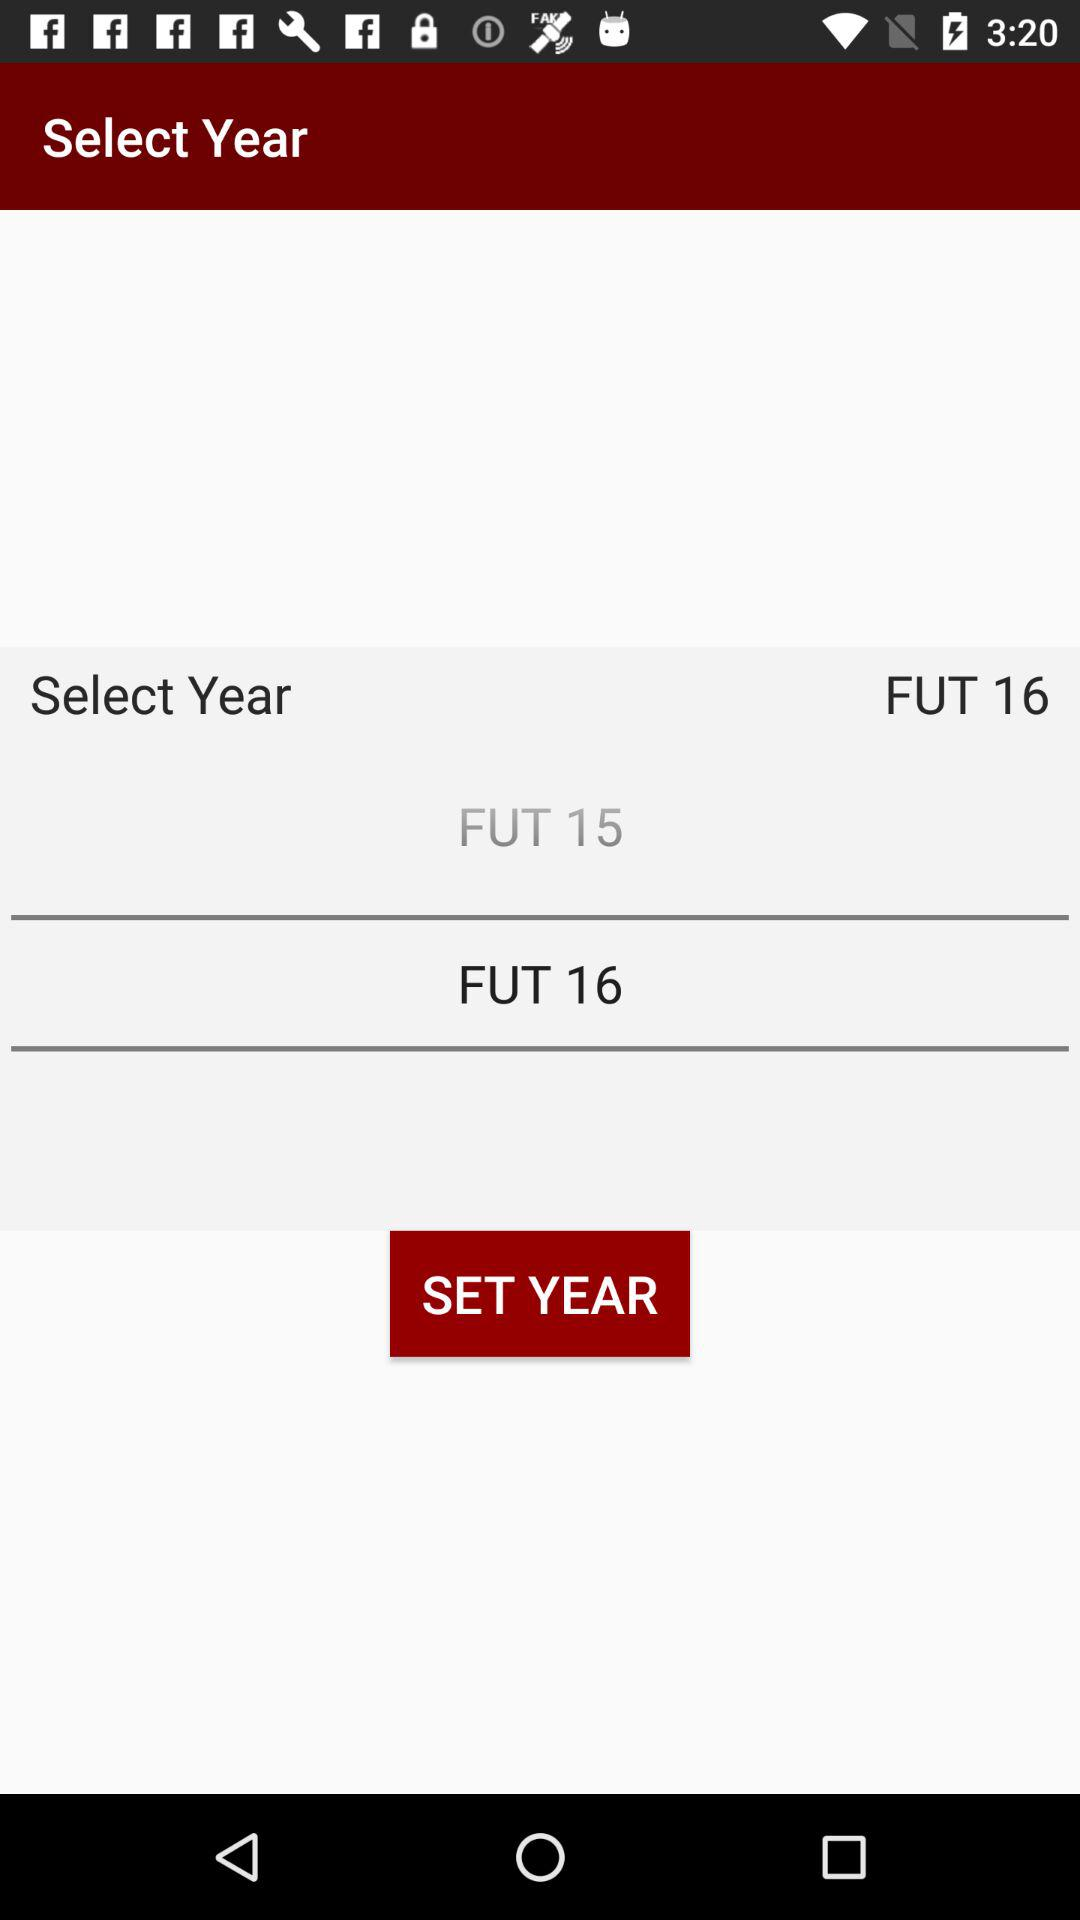How many years are available to select?
Answer the question using a single word or phrase. 2 